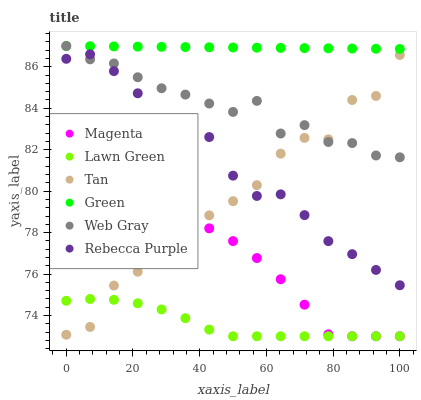Does Lawn Green have the minimum area under the curve?
Answer yes or no. Yes. Does Green have the maximum area under the curve?
Answer yes or no. Yes. Does Web Gray have the minimum area under the curve?
Answer yes or no. No. Does Web Gray have the maximum area under the curve?
Answer yes or no. No. Is Green the smoothest?
Answer yes or no. Yes. Is Tan the roughest?
Answer yes or no. Yes. Is Web Gray the smoothest?
Answer yes or no. No. Is Web Gray the roughest?
Answer yes or no. No. Does Lawn Green have the lowest value?
Answer yes or no. Yes. Does Web Gray have the lowest value?
Answer yes or no. No. Does Green have the highest value?
Answer yes or no. Yes. Does Rebecca Purple have the highest value?
Answer yes or no. No. Is Tan less than Green?
Answer yes or no. Yes. Is Web Gray greater than Lawn Green?
Answer yes or no. Yes. Does Web Gray intersect Green?
Answer yes or no. Yes. Is Web Gray less than Green?
Answer yes or no. No. Is Web Gray greater than Green?
Answer yes or no. No. Does Tan intersect Green?
Answer yes or no. No. 